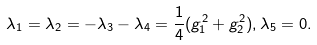Convert formula to latex. <formula><loc_0><loc_0><loc_500><loc_500>\lambda _ { 1 } = \lambda _ { 2 } = - \lambda _ { 3 } - \lambda _ { 4 } = { \frac { 1 } { 4 } } ( g _ { 1 } ^ { 2 } + g _ { 2 } ^ { 2 } ) , \lambda _ { 5 } = 0 .</formula> 